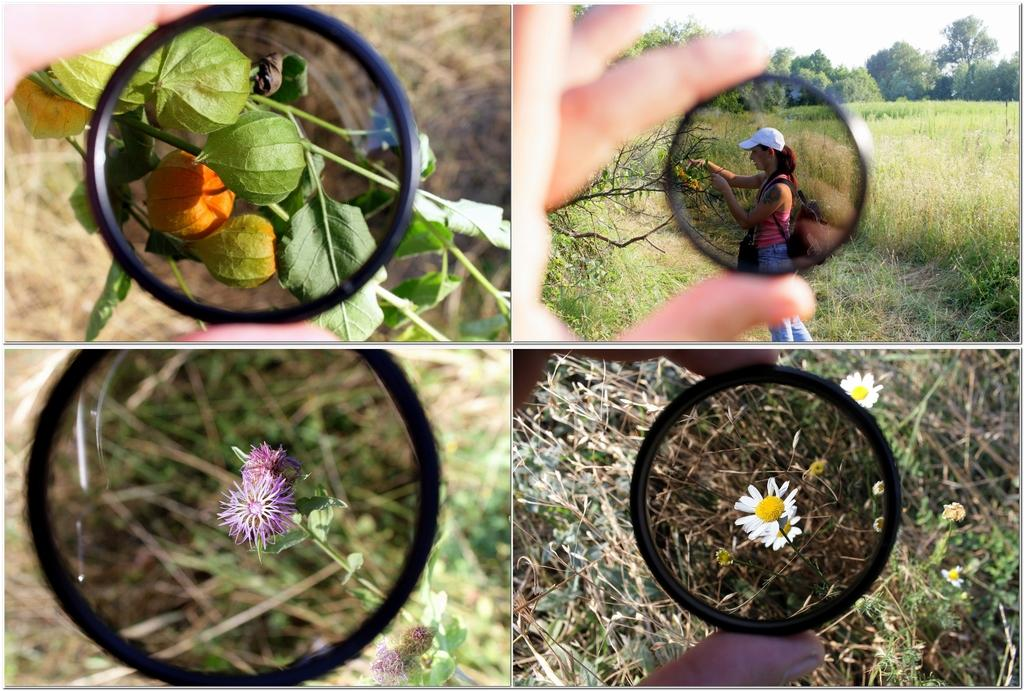What type of image is shown in the collage? The image is a photo collage. What objects can be seen in the photos that have a mirror-like appearance? There are mirror-like objects in the photos. What type of natural elements are present in the photos? There are leaves and flowers in the photos. Can you describe the human presence in the collage? There is a woman standing in one of the images. What type of cup is the woman holding in the photo? There is no cup present in the photo; the woman is not holding anything. What type of toy can be seen in the photo with the earth? There is no toy or earth present in the photo; the image only contains a photo collage with mirror-like objects, leaves, flowers, and a woman. 